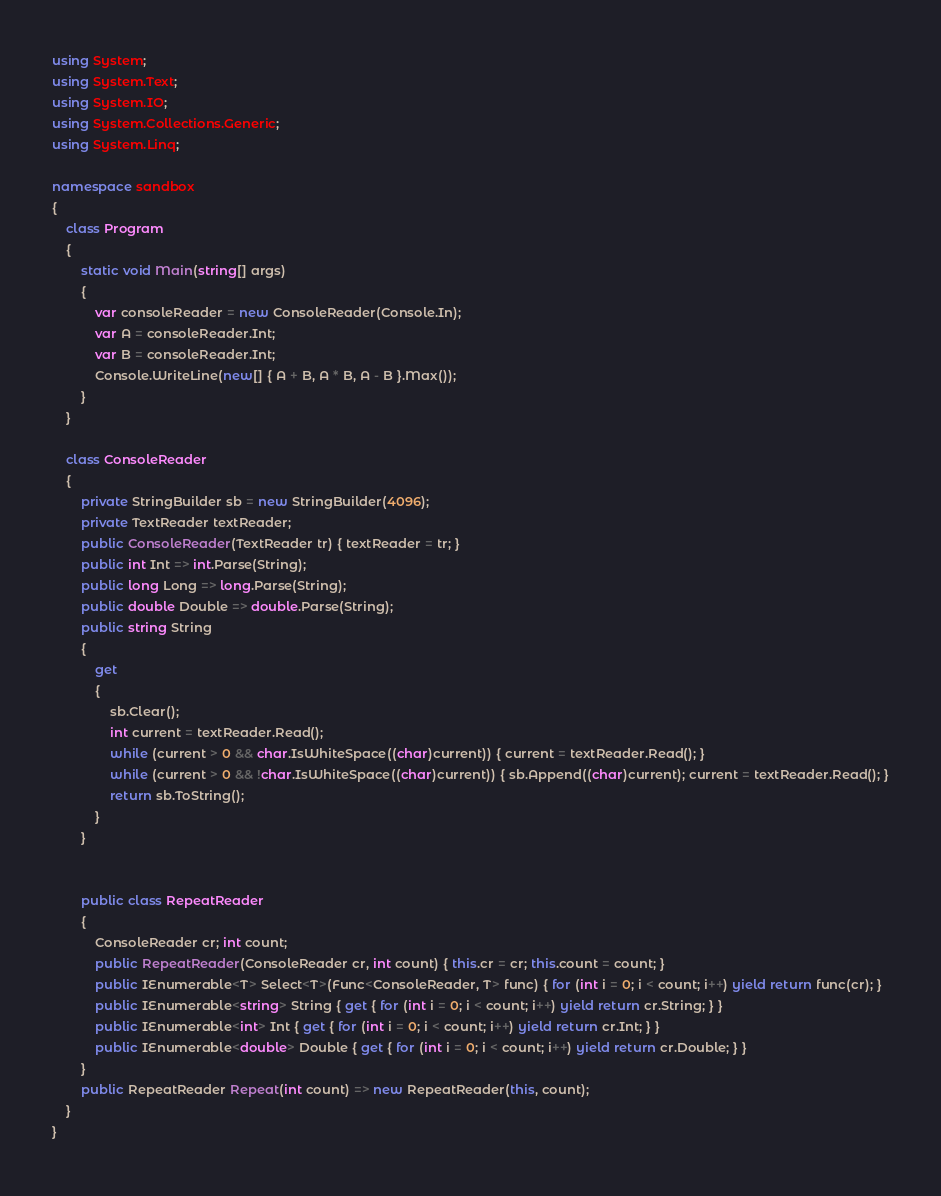Convert code to text. <code><loc_0><loc_0><loc_500><loc_500><_C#_>using System;
using System.Text;
using System.IO;
using System.Collections.Generic;
using System.Linq;

namespace sandbox
{
    class Program
    {
        static void Main(string[] args)
        {
            var consoleReader = new ConsoleReader(Console.In);
            var A = consoleReader.Int;
            var B = consoleReader.Int;
            Console.WriteLine(new[] { A + B, A * B, A - B }.Max());
        }
    }

    class ConsoleReader
    {
        private StringBuilder sb = new StringBuilder(4096);
        private TextReader textReader;
        public ConsoleReader(TextReader tr) { textReader = tr; }
        public int Int => int.Parse(String);
        public long Long => long.Parse(String);
        public double Double => double.Parse(String);
        public string String
        {
            get
            {
                sb.Clear();
                int current = textReader.Read();
                while (current > 0 && char.IsWhiteSpace((char)current)) { current = textReader.Read(); }
                while (current > 0 && !char.IsWhiteSpace((char)current)) { sb.Append((char)current); current = textReader.Read(); }
                return sb.ToString();
            }
        }


        public class RepeatReader
        {
            ConsoleReader cr; int count;
            public RepeatReader(ConsoleReader cr, int count) { this.cr = cr; this.count = count; }
            public IEnumerable<T> Select<T>(Func<ConsoleReader, T> func) { for (int i = 0; i < count; i++) yield return func(cr); }
            public IEnumerable<string> String { get { for (int i = 0; i < count; i++) yield return cr.String; } }
            public IEnumerable<int> Int { get { for (int i = 0; i < count; i++) yield return cr.Int; } }
            public IEnumerable<double> Double { get { for (int i = 0; i < count; i++) yield return cr.Double; } }
        }
        public RepeatReader Repeat(int count) => new RepeatReader(this, count);
    }
}
</code> 